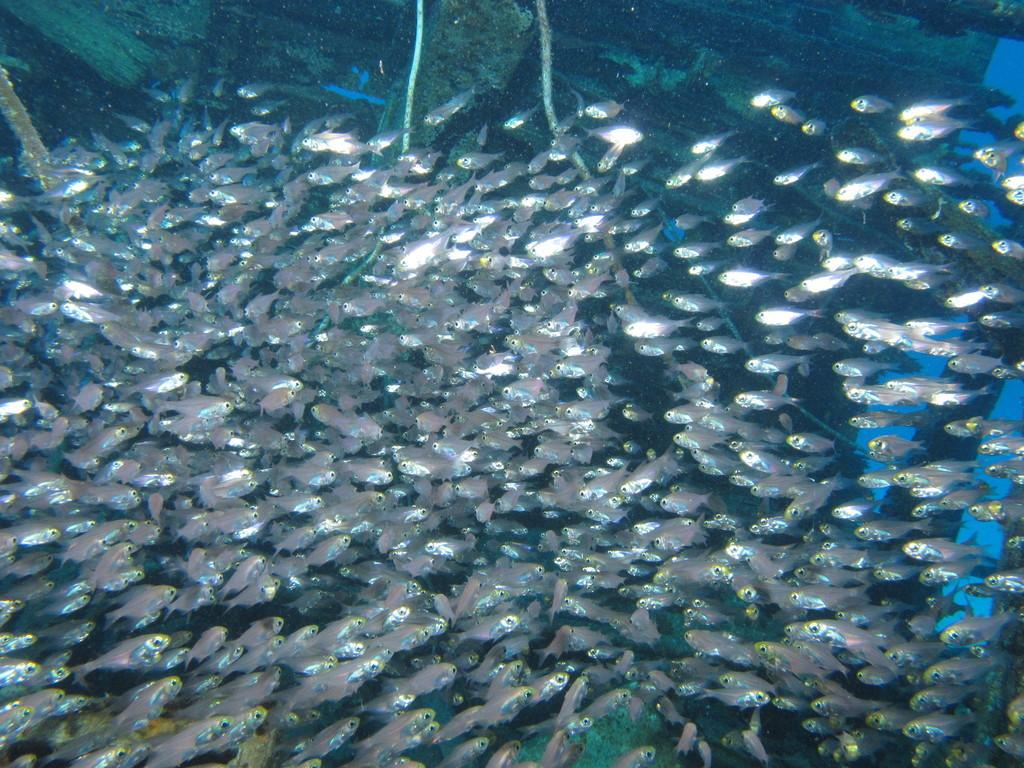What type of animals can be seen in the image? There are fishes in the water in the image. What type of materials are used for the objects visible in the image? There are wooden objects visible in the image. What other items can be seen in the image besides the wooden objects? There are ropes visible in the image. How many cows are present in the image? There are no cows present in the image; it features fishes, wooden objects, and ropes. What type of root can be seen growing in the image? There is no root visible in the image; it features fishes, wooden objects, and ropes. 